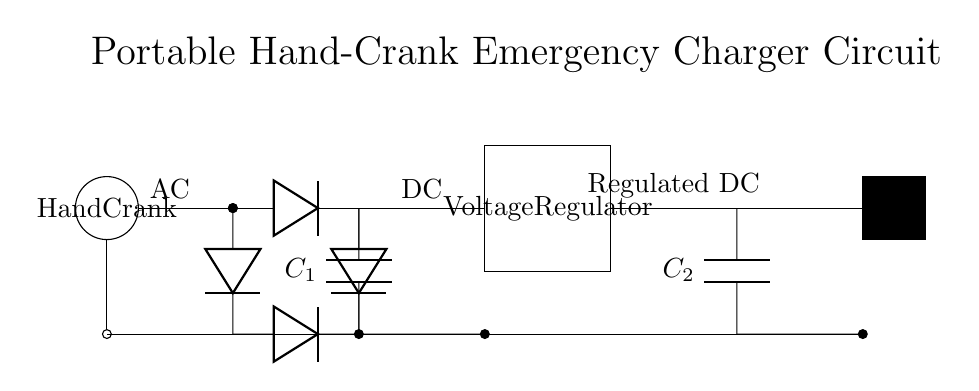What component is used for smoothing? The smoothing capacitor, labeled C1 in the diagram, is used to smooth out the rectified voltage by reducing ripple.
Answer: C1 What is the output type of this circuit? The circuit diagram shows a USB output, which indicates the type of output for charging devices.
Answer: USB How many diodes are in this circuit? There are four diodes used in the rectifier part of the circuit, forming a full-wave rectification configuration.
Answer: 4 What is the purpose of the voltage regulator? The voltage regulator ensures that the output voltage remains stable, regardless of variations in load or input voltage, as indicated by its label in the diagram.
Answer: Regulate voltage What is connected to the hand crank? The hand crank is connected directly to the rectifier, indicating that mechanical rotation generates electrical energy that is then converted to DC.
Answer: Rectifier What does C2 do in this circuit? Capacitor C2 acts as a filtering component at the output to maintain voltage stability and reduce output voltage fluctuations before reaching connected devices.
Answer: Filtering How is the ground represented in this circuit? The ground connections are depicted as a straight line that connects to multiple components, indicating a common reference point for the circuit.
Answer: Common reference 